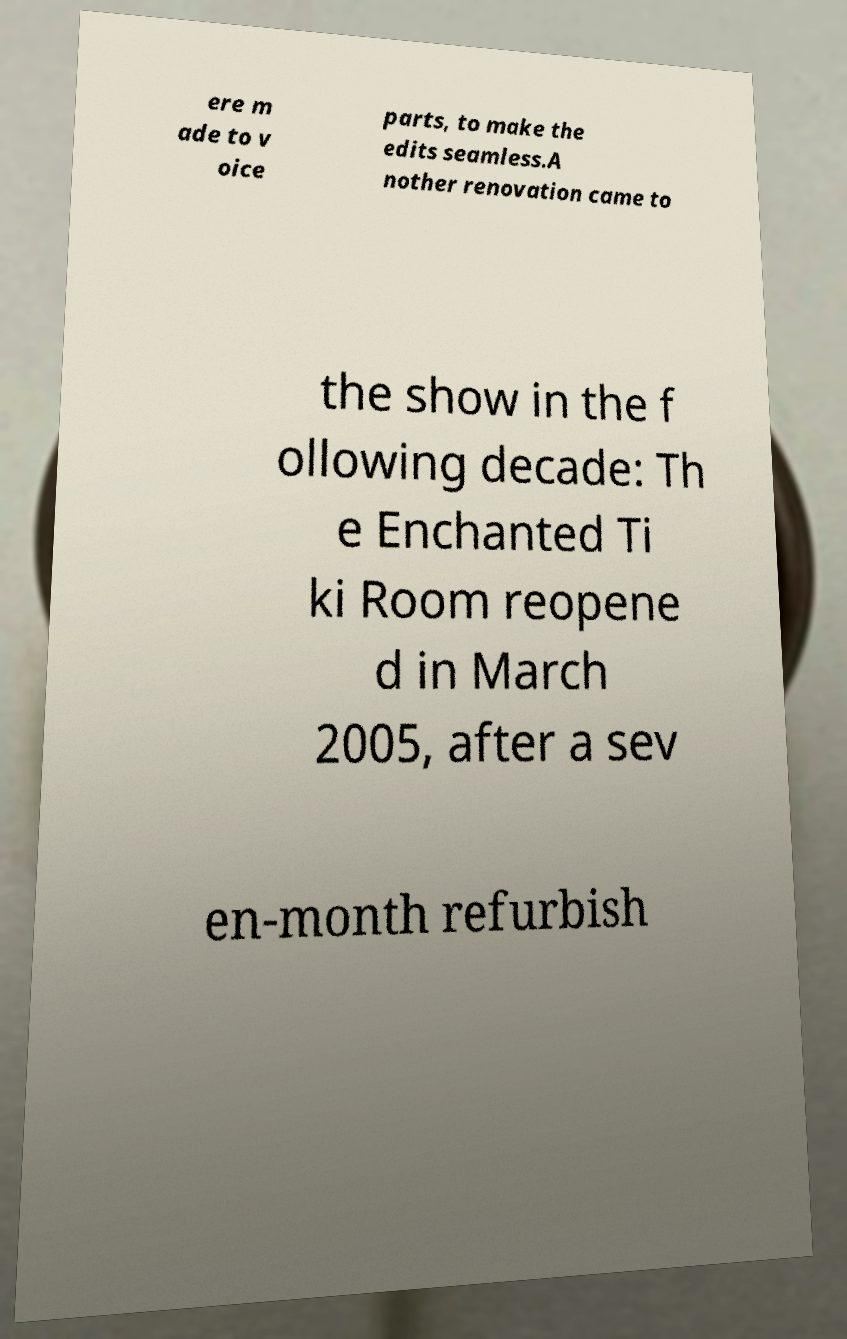Please identify and transcribe the text found in this image. ere m ade to v oice parts, to make the edits seamless.A nother renovation came to the show in the f ollowing decade: Th e Enchanted Ti ki Room reopene d in March 2005, after a sev en-month refurbish 